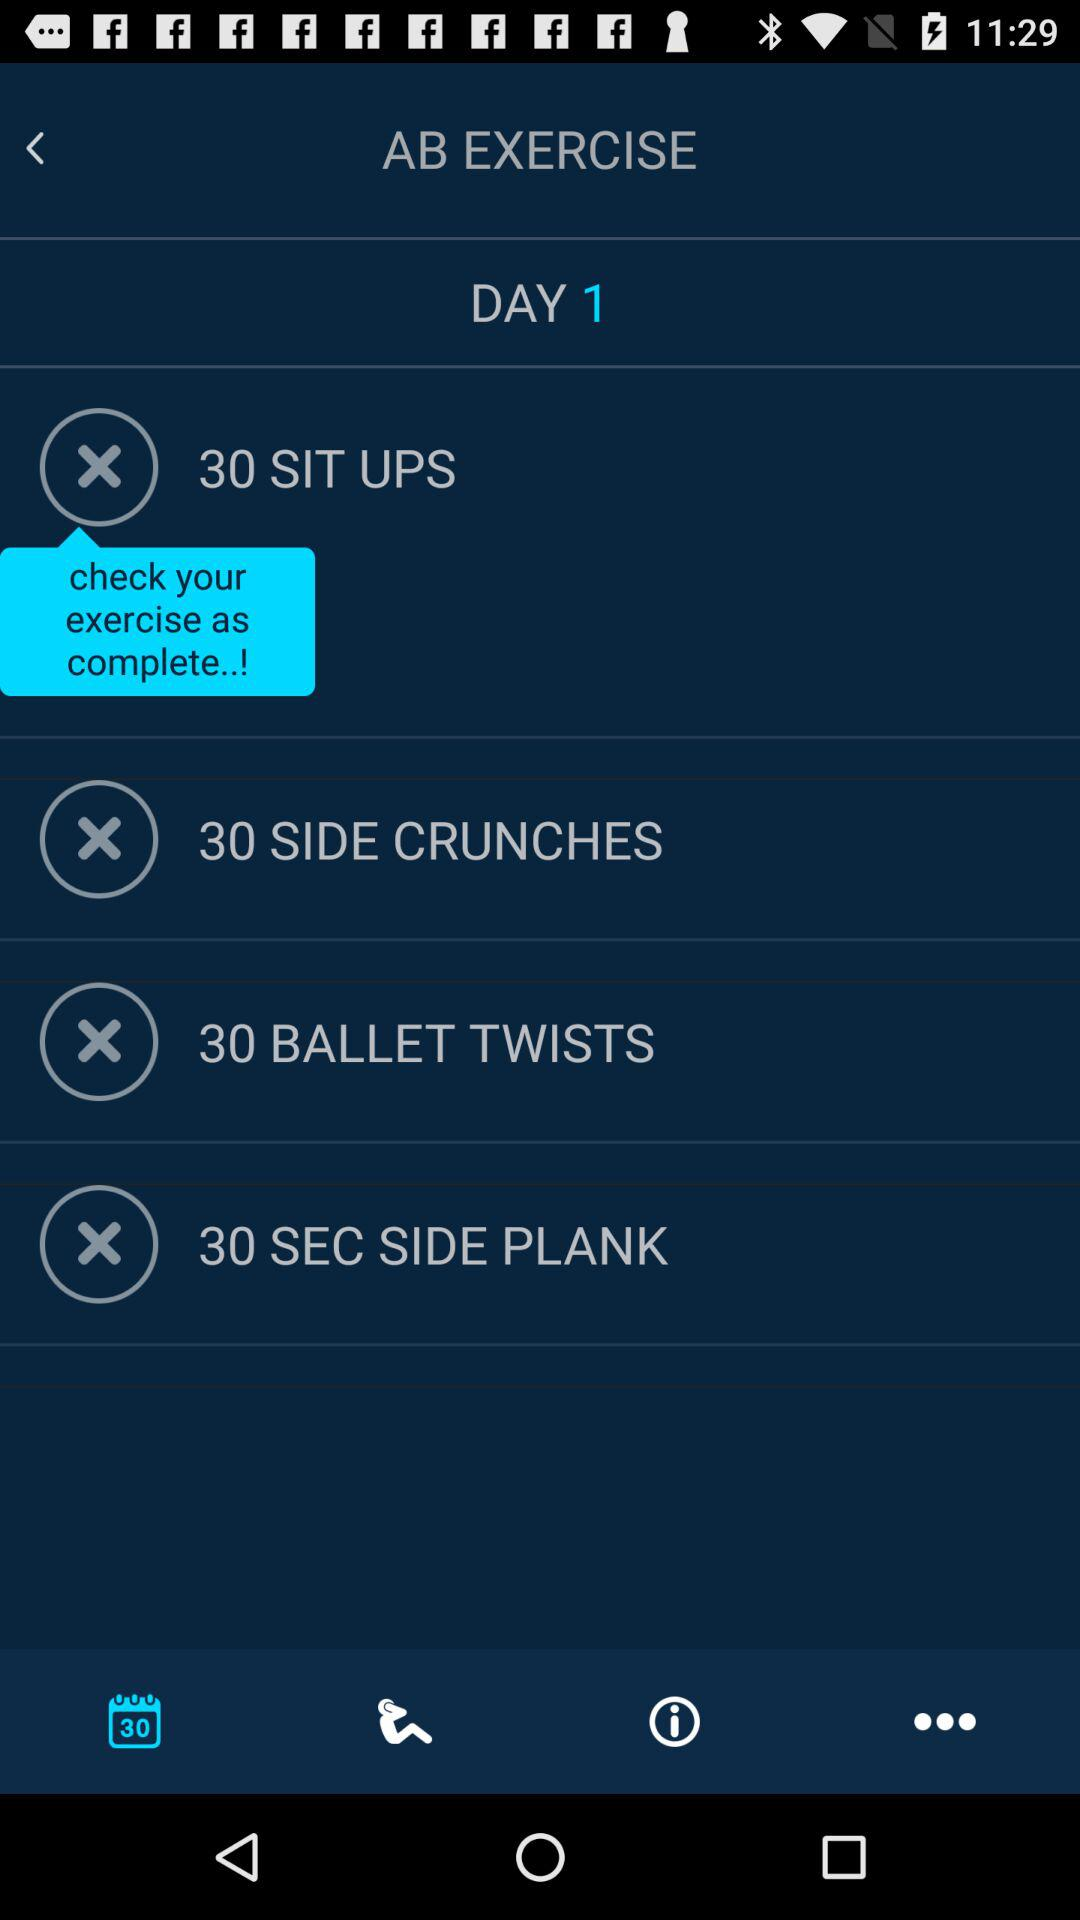What is the number of side crunches? The number of side crunches is 30. 